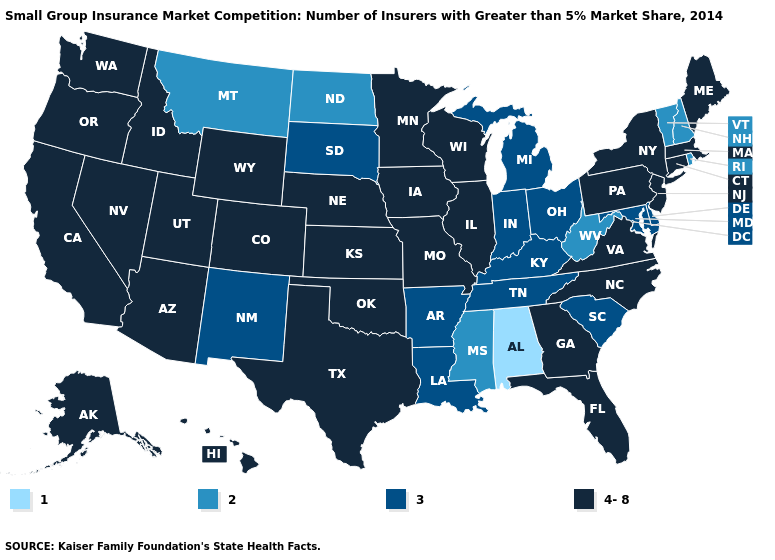Which states have the highest value in the USA?
Answer briefly. Alaska, Arizona, California, Colorado, Connecticut, Florida, Georgia, Hawaii, Idaho, Illinois, Iowa, Kansas, Maine, Massachusetts, Minnesota, Missouri, Nebraska, Nevada, New Jersey, New York, North Carolina, Oklahoma, Oregon, Pennsylvania, Texas, Utah, Virginia, Washington, Wisconsin, Wyoming. What is the highest value in the South ?
Answer briefly. 4-8. Among the states that border Wyoming , which have the highest value?
Concise answer only. Colorado, Idaho, Nebraska, Utah. Name the states that have a value in the range 2?
Write a very short answer. Mississippi, Montana, New Hampshire, North Dakota, Rhode Island, Vermont, West Virginia. Is the legend a continuous bar?
Give a very brief answer. No. Name the states that have a value in the range 1?
Keep it brief. Alabama. Does Kansas have the highest value in the USA?
Keep it brief. Yes. Name the states that have a value in the range 2?
Give a very brief answer. Mississippi, Montana, New Hampshire, North Dakota, Rhode Island, Vermont, West Virginia. What is the value of South Dakota?
Answer briefly. 3. Does Virginia have the lowest value in the South?
Quick response, please. No. Does Virginia have a higher value than Vermont?
Concise answer only. Yes. Does Alabama have the lowest value in the USA?
Quick response, please. Yes. What is the value of Rhode Island?
Be succinct. 2. What is the highest value in states that border Washington?
Be succinct. 4-8. Does Virginia have the highest value in the South?
Keep it brief. Yes. 